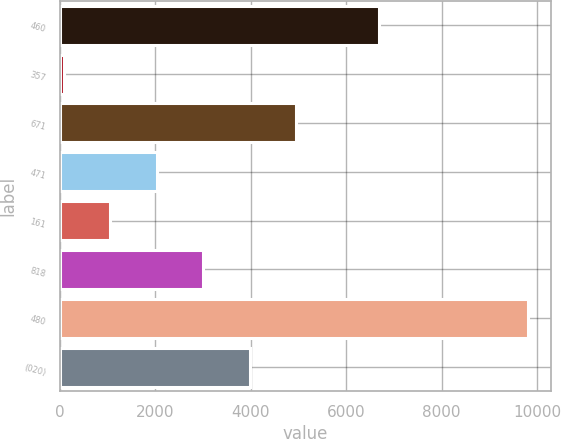<chart> <loc_0><loc_0><loc_500><loc_500><bar_chart><fcel>460<fcel>357<fcel>671<fcel>471<fcel>161<fcel>818<fcel>480<fcel>(020)<nl><fcel>6684<fcel>88<fcel>4944<fcel>2030.4<fcel>1059.2<fcel>3001.6<fcel>9800<fcel>3972.8<nl></chart> 